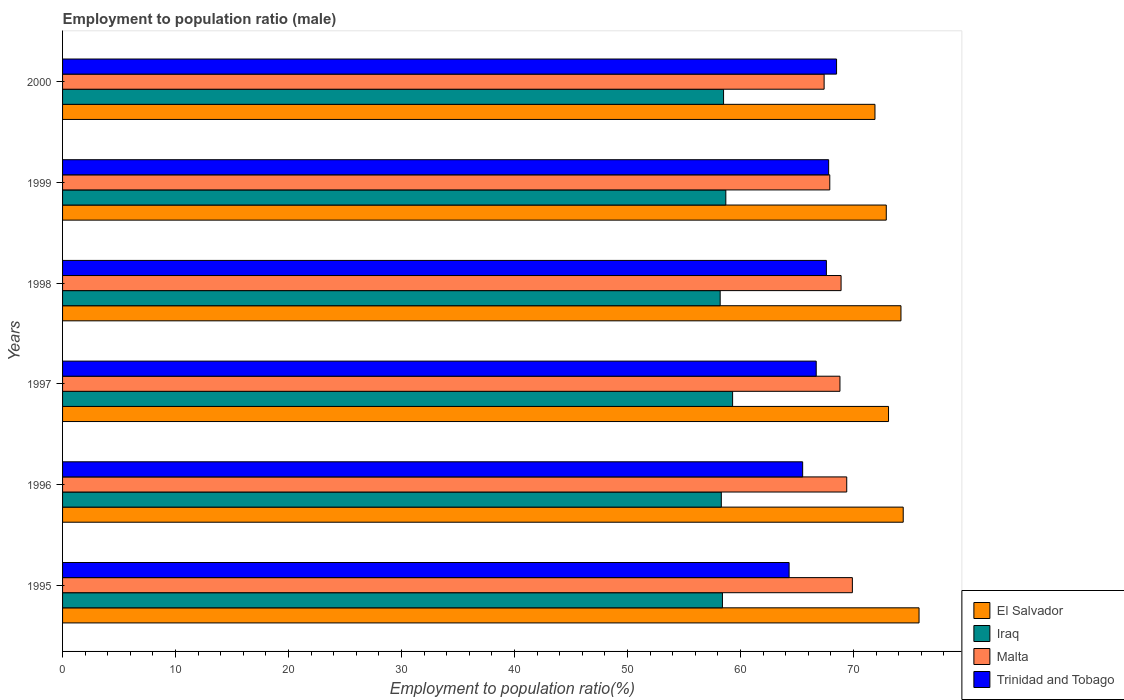How many groups of bars are there?
Give a very brief answer. 6. How many bars are there on the 5th tick from the top?
Offer a very short reply. 4. How many bars are there on the 4th tick from the bottom?
Ensure brevity in your answer.  4. In how many cases, is the number of bars for a given year not equal to the number of legend labels?
Give a very brief answer. 0. What is the employment to population ratio in Trinidad and Tobago in 1995?
Make the answer very short. 64.3. Across all years, what is the maximum employment to population ratio in Malta?
Provide a short and direct response. 69.9. Across all years, what is the minimum employment to population ratio in El Salvador?
Your answer should be compact. 71.9. In which year was the employment to population ratio in Malta minimum?
Your answer should be compact. 2000. What is the total employment to population ratio in El Salvador in the graph?
Make the answer very short. 442.3. What is the difference between the employment to population ratio in Malta in 1995 and that in 2000?
Your response must be concise. 2.5. What is the difference between the employment to population ratio in Iraq in 1995 and the employment to population ratio in Trinidad and Tobago in 1999?
Offer a terse response. -9.4. What is the average employment to population ratio in El Salvador per year?
Give a very brief answer. 73.72. In the year 1999, what is the difference between the employment to population ratio in Iraq and employment to population ratio in Malta?
Your answer should be compact. -9.2. In how many years, is the employment to population ratio in Trinidad and Tobago greater than 10 %?
Make the answer very short. 6. What is the ratio of the employment to population ratio in El Salvador in 1996 to that in 1998?
Give a very brief answer. 1. Is the difference between the employment to population ratio in Iraq in 1997 and 1998 greater than the difference between the employment to population ratio in Malta in 1997 and 1998?
Ensure brevity in your answer.  Yes. What is the difference between the highest and the lowest employment to population ratio in Iraq?
Your response must be concise. 1.1. In how many years, is the employment to population ratio in Iraq greater than the average employment to population ratio in Iraq taken over all years?
Keep it short and to the point. 2. What does the 4th bar from the top in 1995 represents?
Keep it short and to the point. El Salvador. What does the 2nd bar from the bottom in 1995 represents?
Keep it short and to the point. Iraq. Are all the bars in the graph horizontal?
Keep it short and to the point. Yes. How are the legend labels stacked?
Your answer should be very brief. Vertical. What is the title of the graph?
Ensure brevity in your answer.  Employment to population ratio (male). What is the label or title of the Y-axis?
Offer a terse response. Years. What is the Employment to population ratio(%) in El Salvador in 1995?
Your answer should be very brief. 75.8. What is the Employment to population ratio(%) of Iraq in 1995?
Your answer should be compact. 58.4. What is the Employment to population ratio(%) of Malta in 1995?
Offer a terse response. 69.9. What is the Employment to population ratio(%) in Trinidad and Tobago in 1995?
Make the answer very short. 64.3. What is the Employment to population ratio(%) of El Salvador in 1996?
Give a very brief answer. 74.4. What is the Employment to population ratio(%) of Iraq in 1996?
Offer a very short reply. 58.3. What is the Employment to population ratio(%) in Malta in 1996?
Provide a short and direct response. 69.4. What is the Employment to population ratio(%) in Trinidad and Tobago in 1996?
Make the answer very short. 65.5. What is the Employment to population ratio(%) of El Salvador in 1997?
Ensure brevity in your answer.  73.1. What is the Employment to population ratio(%) in Iraq in 1997?
Your answer should be very brief. 59.3. What is the Employment to population ratio(%) in Malta in 1997?
Offer a very short reply. 68.8. What is the Employment to population ratio(%) in Trinidad and Tobago in 1997?
Ensure brevity in your answer.  66.7. What is the Employment to population ratio(%) in El Salvador in 1998?
Provide a succinct answer. 74.2. What is the Employment to population ratio(%) of Iraq in 1998?
Keep it short and to the point. 58.2. What is the Employment to population ratio(%) of Malta in 1998?
Your response must be concise. 68.9. What is the Employment to population ratio(%) of Trinidad and Tobago in 1998?
Your answer should be very brief. 67.6. What is the Employment to population ratio(%) in El Salvador in 1999?
Provide a short and direct response. 72.9. What is the Employment to population ratio(%) in Iraq in 1999?
Offer a terse response. 58.7. What is the Employment to population ratio(%) in Malta in 1999?
Give a very brief answer. 67.9. What is the Employment to population ratio(%) of Trinidad and Tobago in 1999?
Your response must be concise. 67.8. What is the Employment to population ratio(%) in El Salvador in 2000?
Ensure brevity in your answer.  71.9. What is the Employment to population ratio(%) of Iraq in 2000?
Your answer should be very brief. 58.5. What is the Employment to population ratio(%) of Malta in 2000?
Make the answer very short. 67.4. What is the Employment to population ratio(%) of Trinidad and Tobago in 2000?
Your answer should be very brief. 68.5. Across all years, what is the maximum Employment to population ratio(%) in El Salvador?
Provide a short and direct response. 75.8. Across all years, what is the maximum Employment to population ratio(%) in Iraq?
Offer a very short reply. 59.3. Across all years, what is the maximum Employment to population ratio(%) of Malta?
Ensure brevity in your answer.  69.9. Across all years, what is the maximum Employment to population ratio(%) of Trinidad and Tobago?
Provide a succinct answer. 68.5. Across all years, what is the minimum Employment to population ratio(%) of El Salvador?
Ensure brevity in your answer.  71.9. Across all years, what is the minimum Employment to population ratio(%) in Iraq?
Keep it short and to the point. 58.2. Across all years, what is the minimum Employment to population ratio(%) in Malta?
Make the answer very short. 67.4. Across all years, what is the minimum Employment to population ratio(%) of Trinidad and Tobago?
Give a very brief answer. 64.3. What is the total Employment to population ratio(%) of El Salvador in the graph?
Provide a short and direct response. 442.3. What is the total Employment to population ratio(%) in Iraq in the graph?
Keep it short and to the point. 351.4. What is the total Employment to population ratio(%) of Malta in the graph?
Provide a succinct answer. 412.3. What is the total Employment to population ratio(%) of Trinidad and Tobago in the graph?
Your answer should be compact. 400.4. What is the difference between the Employment to population ratio(%) in El Salvador in 1995 and that in 1996?
Your response must be concise. 1.4. What is the difference between the Employment to population ratio(%) of Trinidad and Tobago in 1995 and that in 1996?
Offer a very short reply. -1.2. What is the difference between the Employment to population ratio(%) in El Salvador in 1995 and that in 1997?
Keep it short and to the point. 2.7. What is the difference between the Employment to population ratio(%) in Iraq in 1995 and that in 1997?
Offer a terse response. -0.9. What is the difference between the Employment to population ratio(%) of El Salvador in 1995 and that in 1998?
Provide a succinct answer. 1.6. What is the difference between the Employment to population ratio(%) in Malta in 1995 and that in 1998?
Your answer should be compact. 1. What is the difference between the Employment to population ratio(%) in Trinidad and Tobago in 1995 and that in 1998?
Your response must be concise. -3.3. What is the difference between the Employment to population ratio(%) in Iraq in 1995 and that in 1999?
Your answer should be compact. -0.3. What is the difference between the Employment to population ratio(%) in Malta in 1995 and that in 1999?
Keep it short and to the point. 2. What is the difference between the Employment to population ratio(%) in Trinidad and Tobago in 1995 and that in 1999?
Keep it short and to the point. -3.5. What is the difference between the Employment to population ratio(%) in Malta in 1995 and that in 2000?
Your answer should be very brief. 2.5. What is the difference between the Employment to population ratio(%) in Trinidad and Tobago in 1995 and that in 2000?
Give a very brief answer. -4.2. What is the difference between the Employment to population ratio(%) of Iraq in 1996 and that in 1997?
Your response must be concise. -1. What is the difference between the Employment to population ratio(%) in Trinidad and Tobago in 1996 and that in 1997?
Offer a terse response. -1.2. What is the difference between the Employment to population ratio(%) of El Salvador in 1996 and that in 1998?
Your answer should be very brief. 0.2. What is the difference between the Employment to population ratio(%) of Iraq in 1996 and that in 1998?
Offer a terse response. 0.1. What is the difference between the Employment to population ratio(%) of Malta in 1996 and that in 1998?
Ensure brevity in your answer.  0.5. What is the difference between the Employment to population ratio(%) in El Salvador in 1996 and that in 1999?
Your answer should be very brief. 1.5. What is the difference between the Employment to population ratio(%) in Iraq in 1996 and that in 1999?
Offer a terse response. -0.4. What is the difference between the Employment to population ratio(%) in El Salvador in 1997 and that in 1998?
Offer a terse response. -1.1. What is the difference between the Employment to population ratio(%) of Trinidad and Tobago in 1997 and that in 1998?
Keep it short and to the point. -0.9. What is the difference between the Employment to population ratio(%) in El Salvador in 1997 and that in 1999?
Provide a short and direct response. 0.2. What is the difference between the Employment to population ratio(%) of Iraq in 1997 and that in 2000?
Your response must be concise. 0.8. What is the difference between the Employment to population ratio(%) of Trinidad and Tobago in 1997 and that in 2000?
Make the answer very short. -1.8. What is the difference between the Employment to population ratio(%) of Iraq in 1998 and that in 1999?
Your answer should be very brief. -0.5. What is the difference between the Employment to population ratio(%) in Malta in 1998 and that in 1999?
Provide a succinct answer. 1. What is the difference between the Employment to population ratio(%) in Trinidad and Tobago in 1998 and that in 1999?
Give a very brief answer. -0.2. What is the difference between the Employment to population ratio(%) of El Salvador in 1998 and that in 2000?
Give a very brief answer. 2.3. What is the difference between the Employment to population ratio(%) of Malta in 1998 and that in 2000?
Provide a short and direct response. 1.5. What is the difference between the Employment to population ratio(%) in Iraq in 1999 and that in 2000?
Your answer should be compact. 0.2. What is the difference between the Employment to population ratio(%) of Malta in 1999 and that in 2000?
Give a very brief answer. 0.5. What is the difference between the Employment to population ratio(%) of Trinidad and Tobago in 1999 and that in 2000?
Keep it short and to the point. -0.7. What is the difference between the Employment to population ratio(%) in Iraq in 1995 and the Employment to population ratio(%) in Trinidad and Tobago in 1996?
Make the answer very short. -7.1. What is the difference between the Employment to population ratio(%) of Malta in 1995 and the Employment to population ratio(%) of Trinidad and Tobago in 1996?
Your response must be concise. 4.4. What is the difference between the Employment to population ratio(%) in El Salvador in 1995 and the Employment to population ratio(%) in Iraq in 1997?
Your response must be concise. 16.5. What is the difference between the Employment to population ratio(%) in El Salvador in 1995 and the Employment to population ratio(%) in Malta in 1997?
Your answer should be very brief. 7. What is the difference between the Employment to population ratio(%) of Iraq in 1995 and the Employment to population ratio(%) of Trinidad and Tobago in 1997?
Your response must be concise. -8.3. What is the difference between the Employment to population ratio(%) of Malta in 1995 and the Employment to population ratio(%) of Trinidad and Tobago in 1998?
Provide a succinct answer. 2.3. What is the difference between the Employment to population ratio(%) of El Salvador in 1995 and the Employment to population ratio(%) of Malta in 1999?
Keep it short and to the point. 7.9. What is the difference between the Employment to population ratio(%) of Iraq in 1995 and the Employment to population ratio(%) of Trinidad and Tobago in 1999?
Your answer should be compact. -9.4. What is the difference between the Employment to population ratio(%) in Malta in 1995 and the Employment to population ratio(%) in Trinidad and Tobago in 1999?
Ensure brevity in your answer.  2.1. What is the difference between the Employment to population ratio(%) in El Salvador in 1995 and the Employment to population ratio(%) in Iraq in 2000?
Provide a short and direct response. 17.3. What is the difference between the Employment to population ratio(%) in El Salvador in 1995 and the Employment to population ratio(%) in Trinidad and Tobago in 2000?
Provide a succinct answer. 7.3. What is the difference between the Employment to population ratio(%) in Iraq in 1995 and the Employment to population ratio(%) in Malta in 2000?
Provide a short and direct response. -9. What is the difference between the Employment to population ratio(%) of Iraq in 1995 and the Employment to population ratio(%) of Trinidad and Tobago in 2000?
Your answer should be very brief. -10.1. What is the difference between the Employment to population ratio(%) in Iraq in 1996 and the Employment to population ratio(%) in Trinidad and Tobago in 1997?
Make the answer very short. -8.4. What is the difference between the Employment to population ratio(%) of El Salvador in 1996 and the Employment to population ratio(%) of Iraq in 1998?
Provide a short and direct response. 16.2. What is the difference between the Employment to population ratio(%) of El Salvador in 1996 and the Employment to population ratio(%) of Trinidad and Tobago in 1998?
Your answer should be compact. 6.8. What is the difference between the Employment to population ratio(%) in Iraq in 1996 and the Employment to population ratio(%) in Trinidad and Tobago in 1998?
Offer a very short reply. -9.3. What is the difference between the Employment to population ratio(%) of Malta in 1996 and the Employment to population ratio(%) of Trinidad and Tobago in 1998?
Ensure brevity in your answer.  1.8. What is the difference between the Employment to population ratio(%) in El Salvador in 1996 and the Employment to population ratio(%) in Malta in 1999?
Provide a short and direct response. 6.5. What is the difference between the Employment to population ratio(%) of Iraq in 1996 and the Employment to population ratio(%) of Trinidad and Tobago in 1999?
Your response must be concise. -9.5. What is the difference between the Employment to population ratio(%) of Malta in 1996 and the Employment to population ratio(%) of Trinidad and Tobago in 1999?
Give a very brief answer. 1.6. What is the difference between the Employment to population ratio(%) of Iraq in 1996 and the Employment to population ratio(%) of Malta in 2000?
Offer a very short reply. -9.1. What is the difference between the Employment to population ratio(%) of Malta in 1996 and the Employment to population ratio(%) of Trinidad and Tobago in 2000?
Your answer should be compact. 0.9. What is the difference between the Employment to population ratio(%) in El Salvador in 1997 and the Employment to population ratio(%) in Iraq in 1998?
Give a very brief answer. 14.9. What is the difference between the Employment to population ratio(%) in El Salvador in 1997 and the Employment to population ratio(%) in Trinidad and Tobago in 1998?
Make the answer very short. 5.5. What is the difference between the Employment to population ratio(%) of Iraq in 1997 and the Employment to population ratio(%) of Malta in 1998?
Your response must be concise. -9.6. What is the difference between the Employment to population ratio(%) of Malta in 1997 and the Employment to population ratio(%) of Trinidad and Tobago in 1998?
Offer a very short reply. 1.2. What is the difference between the Employment to population ratio(%) of El Salvador in 1997 and the Employment to population ratio(%) of Malta in 1999?
Ensure brevity in your answer.  5.2. What is the difference between the Employment to population ratio(%) in Iraq in 1997 and the Employment to population ratio(%) in Malta in 1999?
Give a very brief answer. -8.6. What is the difference between the Employment to population ratio(%) of Iraq in 1997 and the Employment to population ratio(%) of Trinidad and Tobago in 1999?
Offer a very short reply. -8.5. What is the difference between the Employment to population ratio(%) of El Salvador in 1997 and the Employment to population ratio(%) of Malta in 2000?
Your response must be concise. 5.7. What is the difference between the Employment to population ratio(%) in El Salvador in 1997 and the Employment to population ratio(%) in Trinidad and Tobago in 2000?
Your answer should be compact. 4.6. What is the difference between the Employment to population ratio(%) of El Salvador in 1998 and the Employment to population ratio(%) of Iraq in 1999?
Ensure brevity in your answer.  15.5. What is the difference between the Employment to population ratio(%) of Malta in 1998 and the Employment to population ratio(%) of Trinidad and Tobago in 1999?
Your response must be concise. 1.1. What is the difference between the Employment to population ratio(%) of El Salvador in 1998 and the Employment to population ratio(%) of Iraq in 2000?
Offer a very short reply. 15.7. What is the difference between the Employment to population ratio(%) of El Salvador in 1998 and the Employment to population ratio(%) of Malta in 2000?
Make the answer very short. 6.8. What is the difference between the Employment to population ratio(%) of Iraq in 1998 and the Employment to population ratio(%) of Malta in 2000?
Ensure brevity in your answer.  -9.2. What is the difference between the Employment to population ratio(%) in El Salvador in 1999 and the Employment to population ratio(%) in Malta in 2000?
Your answer should be compact. 5.5. What is the difference between the Employment to population ratio(%) of Malta in 1999 and the Employment to population ratio(%) of Trinidad and Tobago in 2000?
Your answer should be very brief. -0.6. What is the average Employment to population ratio(%) of El Salvador per year?
Ensure brevity in your answer.  73.72. What is the average Employment to population ratio(%) in Iraq per year?
Offer a terse response. 58.57. What is the average Employment to population ratio(%) in Malta per year?
Offer a terse response. 68.72. What is the average Employment to population ratio(%) in Trinidad and Tobago per year?
Keep it short and to the point. 66.73. In the year 1995, what is the difference between the Employment to population ratio(%) in Iraq and Employment to population ratio(%) in Trinidad and Tobago?
Give a very brief answer. -5.9. In the year 1995, what is the difference between the Employment to population ratio(%) of Malta and Employment to population ratio(%) of Trinidad and Tobago?
Offer a very short reply. 5.6. In the year 1996, what is the difference between the Employment to population ratio(%) of El Salvador and Employment to population ratio(%) of Iraq?
Make the answer very short. 16.1. In the year 1997, what is the difference between the Employment to population ratio(%) in El Salvador and Employment to population ratio(%) in Iraq?
Your response must be concise. 13.8. In the year 1997, what is the difference between the Employment to population ratio(%) in El Salvador and Employment to population ratio(%) in Malta?
Make the answer very short. 4.3. In the year 1997, what is the difference between the Employment to population ratio(%) in Iraq and Employment to population ratio(%) in Malta?
Your response must be concise. -9.5. In the year 1998, what is the difference between the Employment to population ratio(%) in El Salvador and Employment to population ratio(%) in Iraq?
Offer a terse response. 16. In the year 1998, what is the difference between the Employment to population ratio(%) in El Salvador and Employment to population ratio(%) in Malta?
Offer a terse response. 5.3. In the year 1998, what is the difference between the Employment to population ratio(%) in Iraq and Employment to population ratio(%) in Trinidad and Tobago?
Make the answer very short. -9.4. In the year 1999, what is the difference between the Employment to population ratio(%) in El Salvador and Employment to population ratio(%) in Iraq?
Offer a terse response. 14.2. In the year 2000, what is the difference between the Employment to population ratio(%) in El Salvador and Employment to population ratio(%) in Iraq?
Keep it short and to the point. 13.4. In the year 2000, what is the difference between the Employment to population ratio(%) of Iraq and Employment to population ratio(%) of Malta?
Make the answer very short. -8.9. In the year 2000, what is the difference between the Employment to population ratio(%) in Iraq and Employment to population ratio(%) in Trinidad and Tobago?
Ensure brevity in your answer.  -10. In the year 2000, what is the difference between the Employment to population ratio(%) of Malta and Employment to population ratio(%) of Trinidad and Tobago?
Ensure brevity in your answer.  -1.1. What is the ratio of the Employment to population ratio(%) in El Salvador in 1995 to that in 1996?
Offer a very short reply. 1.02. What is the ratio of the Employment to population ratio(%) of Iraq in 1995 to that in 1996?
Ensure brevity in your answer.  1. What is the ratio of the Employment to population ratio(%) of Malta in 1995 to that in 1996?
Give a very brief answer. 1.01. What is the ratio of the Employment to population ratio(%) in Trinidad and Tobago in 1995 to that in 1996?
Offer a very short reply. 0.98. What is the ratio of the Employment to population ratio(%) in El Salvador in 1995 to that in 1997?
Keep it short and to the point. 1.04. What is the ratio of the Employment to population ratio(%) of Iraq in 1995 to that in 1997?
Your answer should be very brief. 0.98. What is the ratio of the Employment to population ratio(%) of El Salvador in 1995 to that in 1998?
Provide a short and direct response. 1.02. What is the ratio of the Employment to population ratio(%) of Malta in 1995 to that in 1998?
Give a very brief answer. 1.01. What is the ratio of the Employment to population ratio(%) of Trinidad and Tobago in 1995 to that in 1998?
Your answer should be very brief. 0.95. What is the ratio of the Employment to population ratio(%) of El Salvador in 1995 to that in 1999?
Offer a terse response. 1.04. What is the ratio of the Employment to population ratio(%) in Malta in 1995 to that in 1999?
Your response must be concise. 1.03. What is the ratio of the Employment to population ratio(%) in Trinidad and Tobago in 1995 to that in 1999?
Your answer should be compact. 0.95. What is the ratio of the Employment to population ratio(%) in El Salvador in 1995 to that in 2000?
Offer a terse response. 1.05. What is the ratio of the Employment to population ratio(%) in Malta in 1995 to that in 2000?
Your response must be concise. 1.04. What is the ratio of the Employment to population ratio(%) in Trinidad and Tobago in 1995 to that in 2000?
Provide a succinct answer. 0.94. What is the ratio of the Employment to population ratio(%) in El Salvador in 1996 to that in 1997?
Give a very brief answer. 1.02. What is the ratio of the Employment to population ratio(%) in Iraq in 1996 to that in 1997?
Your answer should be compact. 0.98. What is the ratio of the Employment to population ratio(%) in Malta in 1996 to that in 1997?
Your response must be concise. 1.01. What is the ratio of the Employment to population ratio(%) in Trinidad and Tobago in 1996 to that in 1997?
Give a very brief answer. 0.98. What is the ratio of the Employment to population ratio(%) in Iraq in 1996 to that in 1998?
Your answer should be very brief. 1. What is the ratio of the Employment to population ratio(%) of Malta in 1996 to that in 1998?
Keep it short and to the point. 1.01. What is the ratio of the Employment to population ratio(%) of Trinidad and Tobago in 1996 to that in 1998?
Give a very brief answer. 0.97. What is the ratio of the Employment to population ratio(%) in El Salvador in 1996 to that in 1999?
Your answer should be compact. 1.02. What is the ratio of the Employment to population ratio(%) in Malta in 1996 to that in 1999?
Your answer should be very brief. 1.02. What is the ratio of the Employment to population ratio(%) in Trinidad and Tobago in 1996 to that in 1999?
Offer a very short reply. 0.97. What is the ratio of the Employment to population ratio(%) in El Salvador in 1996 to that in 2000?
Give a very brief answer. 1.03. What is the ratio of the Employment to population ratio(%) in Iraq in 1996 to that in 2000?
Make the answer very short. 1. What is the ratio of the Employment to population ratio(%) of Malta in 1996 to that in 2000?
Offer a very short reply. 1.03. What is the ratio of the Employment to population ratio(%) of Trinidad and Tobago in 1996 to that in 2000?
Your answer should be compact. 0.96. What is the ratio of the Employment to population ratio(%) in El Salvador in 1997 to that in 1998?
Provide a succinct answer. 0.99. What is the ratio of the Employment to population ratio(%) of Iraq in 1997 to that in 1998?
Ensure brevity in your answer.  1.02. What is the ratio of the Employment to population ratio(%) of Trinidad and Tobago in 1997 to that in 1998?
Make the answer very short. 0.99. What is the ratio of the Employment to population ratio(%) in El Salvador in 1997 to that in 1999?
Provide a succinct answer. 1. What is the ratio of the Employment to population ratio(%) of Iraq in 1997 to that in 1999?
Your response must be concise. 1.01. What is the ratio of the Employment to population ratio(%) in Malta in 1997 to that in 1999?
Ensure brevity in your answer.  1.01. What is the ratio of the Employment to population ratio(%) of Trinidad and Tobago in 1997 to that in 1999?
Your response must be concise. 0.98. What is the ratio of the Employment to population ratio(%) in El Salvador in 1997 to that in 2000?
Offer a terse response. 1.02. What is the ratio of the Employment to population ratio(%) of Iraq in 1997 to that in 2000?
Offer a terse response. 1.01. What is the ratio of the Employment to population ratio(%) in Malta in 1997 to that in 2000?
Offer a terse response. 1.02. What is the ratio of the Employment to population ratio(%) in Trinidad and Tobago in 1997 to that in 2000?
Make the answer very short. 0.97. What is the ratio of the Employment to population ratio(%) in El Salvador in 1998 to that in 1999?
Provide a succinct answer. 1.02. What is the ratio of the Employment to population ratio(%) of Iraq in 1998 to that in 1999?
Keep it short and to the point. 0.99. What is the ratio of the Employment to population ratio(%) in Malta in 1998 to that in 1999?
Ensure brevity in your answer.  1.01. What is the ratio of the Employment to population ratio(%) of El Salvador in 1998 to that in 2000?
Provide a short and direct response. 1.03. What is the ratio of the Employment to population ratio(%) in Iraq in 1998 to that in 2000?
Offer a terse response. 0.99. What is the ratio of the Employment to population ratio(%) of Malta in 1998 to that in 2000?
Offer a terse response. 1.02. What is the ratio of the Employment to population ratio(%) in Trinidad and Tobago in 1998 to that in 2000?
Make the answer very short. 0.99. What is the ratio of the Employment to population ratio(%) of El Salvador in 1999 to that in 2000?
Keep it short and to the point. 1.01. What is the ratio of the Employment to population ratio(%) in Iraq in 1999 to that in 2000?
Provide a short and direct response. 1. What is the ratio of the Employment to population ratio(%) in Malta in 1999 to that in 2000?
Your response must be concise. 1.01. What is the ratio of the Employment to population ratio(%) in Trinidad and Tobago in 1999 to that in 2000?
Ensure brevity in your answer.  0.99. What is the difference between the highest and the second highest Employment to population ratio(%) of El Salvador?
Keep it short and to the point. 1.4. What is the difference between the highest and the second highest Employment to population ratio(%) of Trinidad and Tobago?
Keep it short and to the point. 0.7. What is the difference between the highest and the lowest Employment to population ratio(%) of El Salvador?
Your answer should be very brief. 3.9. What is the difference between the highest and the lowest Employment to population ratio(%) in Iraq?
Keep it short and to the point. 1.1. What is the difference between the highest and the lowest Employment to population ratio(%) of Trinidad and Tobago?
Provide a succinct answer. 4.2. 